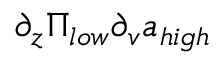Convert formula to latex. <formula><loc_0><loc_0><loc_500><loc_500>\partial _ { z } \Pi _ { l o w } \partial _ { v } a _ { h i g h }</formula> 